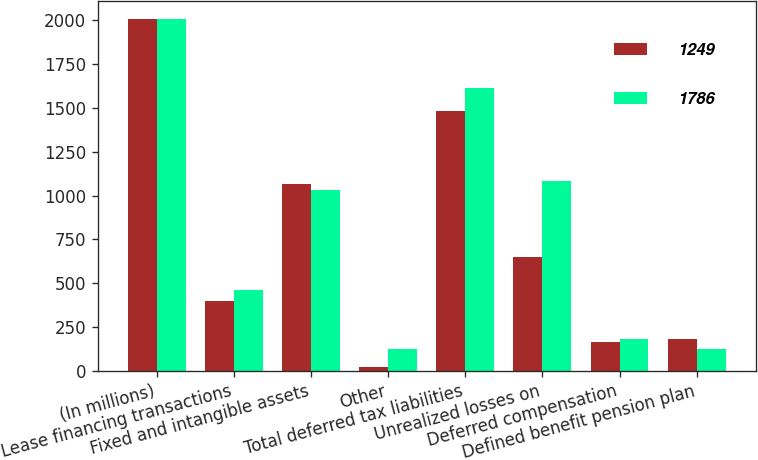Convert chart. <chart><loc_0><loc_0><loc_500><loc_500><stacked_bar_chart><ecel><fcel>(In millions)<fcel>Lease financing transactions<fcel>Fixed and intangible assets<fcel>Other<fcel>Total deferred tax liabilities<fcel>Unrealized losses on<fcel>Deferred compensation<fcel>Defined benefit pension plan<nl><fcel>1249<fcel>2011<fcel>397<fcel>1067<fcel>21<fcel>1485<fcel>651<fcel>162<fcel>180<nl><fcel>1786<fcel>2010<fcel>463<fcel>1029<fcel>122<fcel>1614<fcel>1083<fcel>183<fcel>121<nl></chart> 